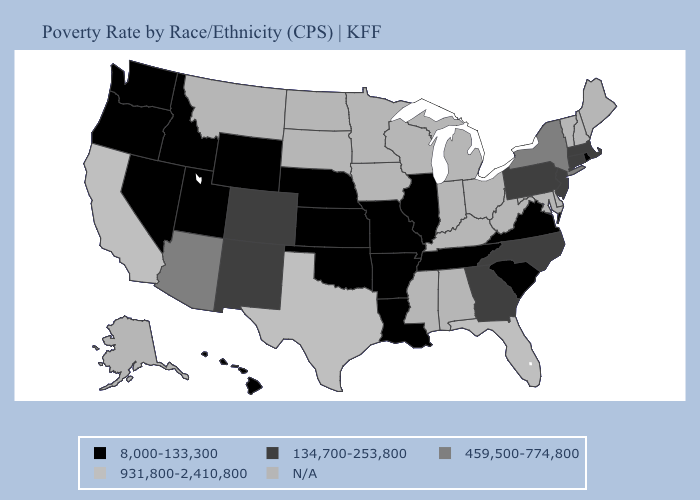What is the value of Kansas?
Short answer required. 8,000-133,300. Does Massachusetts have the highest value in the Northeast?
Quick response, please. No. Name the states that have a value in the range N/A?
Concise answer only. Alabama, Alaska, Delaware, Indiana, Iowa, Kentucky, Maine, Maryland, Michigan, Minnesota, Mississippi, Montana, New Hampshire, North Dakota, Ohio, South Dakota, Vermont, West Virginia, Wisconsin. What is the value of Georgia?
Concise answer only. 134,700-253,800. Does Florida have the highest value in the USA?
Give a very brief answer. Yes. Name the states that have a value in the range 134,700-253,800?
Write a very short answer. Colorado, Connecticut, Georgia, Massachusetts, New Jersey, New Mexico, North Carolina, Pennsylvania. Name the states that have a value in the range N/A?
Be succinct. Alabama, Alaska, Delaware, Indiana, Iowa, Kentucky, Maine, Maryland, Michigan, Minnesota, Mississippi, Montana, New Hampshire, North Dakota, Ohio, South Dakota, Vermont, West Virginia, Wisconsin. Name the states that have a value in the range N/A?
Be succinct. Alabama, Alaska, Delaware, Indiana, Iowa, Kentucky, Maine, Maryland, Michigan, Minnesota, Mississippi, Montana, New Hampshire, North Dakota, Ohio, South Dakota, Vermont, West Virginia, Wisconsin. What is the value of Connecticut?
Concise answer only. 134,700-253,800. What is the value of Nebraska?
Short answer required. 8,000-133,300. Among the states that border Connecticut , which have the highest value?
Keep it brief. New York. What is the highest value in states that border Nebraska?
Write a very short answer. 134,700-253,800. 